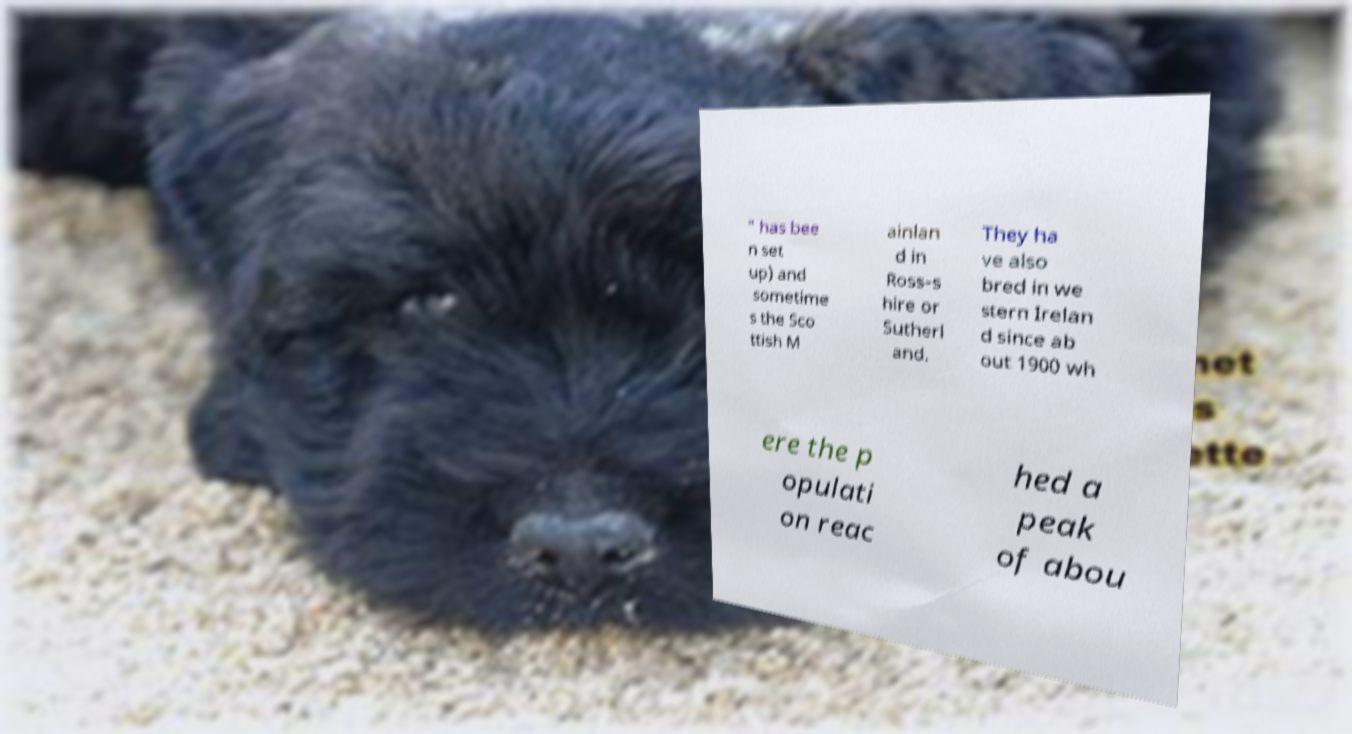Can you read and provide the text displayed in the image?This photo seems to have some interesting text. Can you extract and type it out for me? " has bee n set up) and sometime s the Sco ttish M ainlan d in Ross-s hire or Sutherl and. They ha ve also bred in we stern Irelan d since ab out 1900 wh ere the p opulati on reac hed a peak of abou 